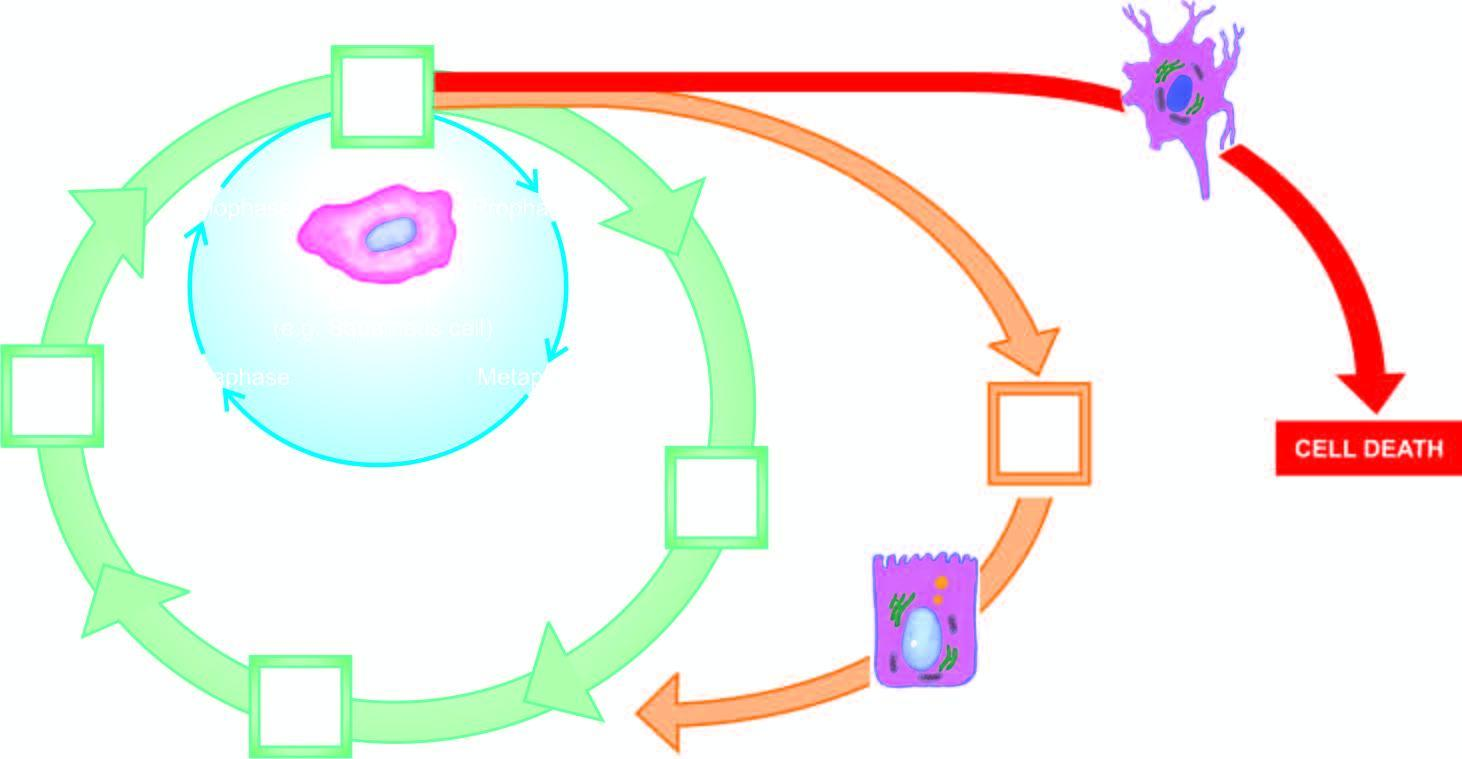does circle shown with yellow-orange line represent cell cycle for stable cells?
Answer the question using a single word or phrase. Yes 